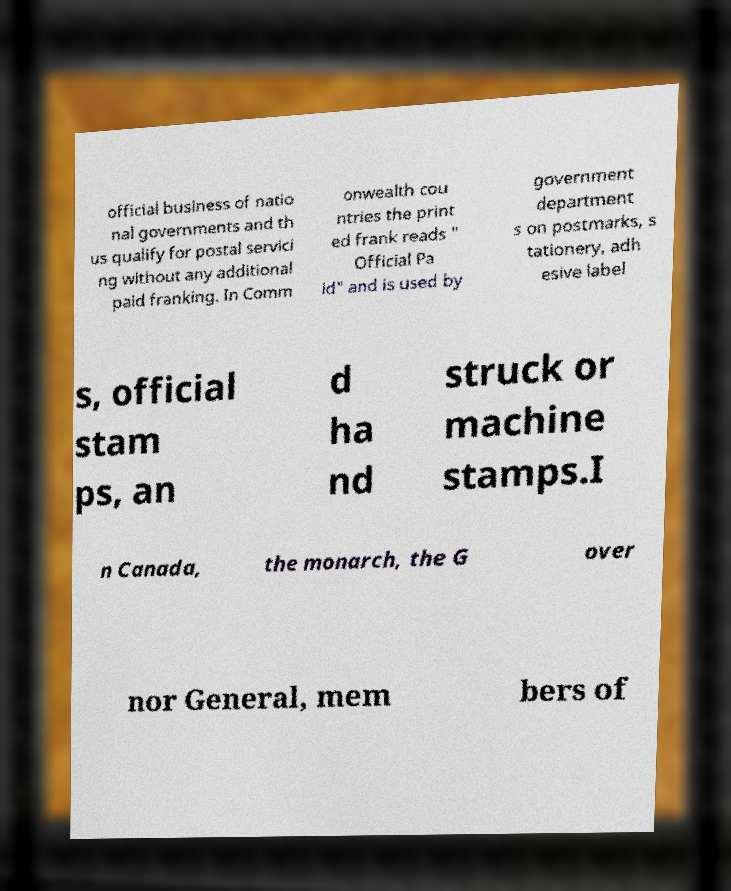Can you accurately transcribe the text from the provided image for me? official business of natio nal governments and th us qualify for postal servici ng without any additional paid franking. In Comm onwealth cou ntries the print ed frank reads " Official Pa id" and is used by government department s on postmarks, s tationery, adh esive label s, official stam ps, an d ha nd struck or machine stamps.I n Canada, the monarch, the G over nor General, mem bers of 